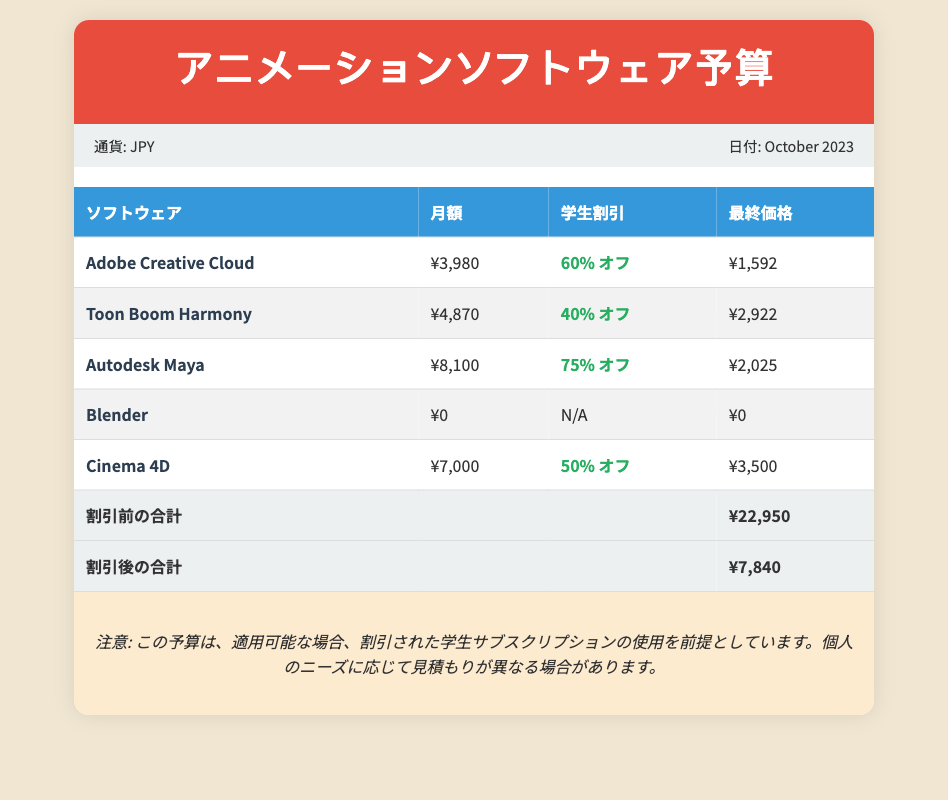What is the software with the highest original monthly cost? The software with the highest original monthly cost is Autodesk Maya at ¥8,100.
Answer: ¥8,100 What discount does Adobe Creative Cloud offer for students? Adobe Creative Cloud offers a 60% discount for students.
Answer: 60% オフ What is the final price of Toon Boom Harmony after the student discount? The final price of Toon Boom Harmony after the student discount is ¥2,922.
Answer: ¥2,922 What is the total price before discounts? The total price before discounts, which sums all original monthly costs, is ¥22,950.
Answer: ¥22,950 Which software is free of charge? The software that is free of charge is Blender.
Answer: ¥0 What is the total price after discounts? The total price after discounts is ¥7,840.
Answer: ¥7,840 Which software offers a 75% discount? The software that offers a 75% discount is Autodesk Maya.
Answer: Autodesk Maya What is the currency used in this budget? The currency used in this budget is Japanese Yen.
Answer: JPY 